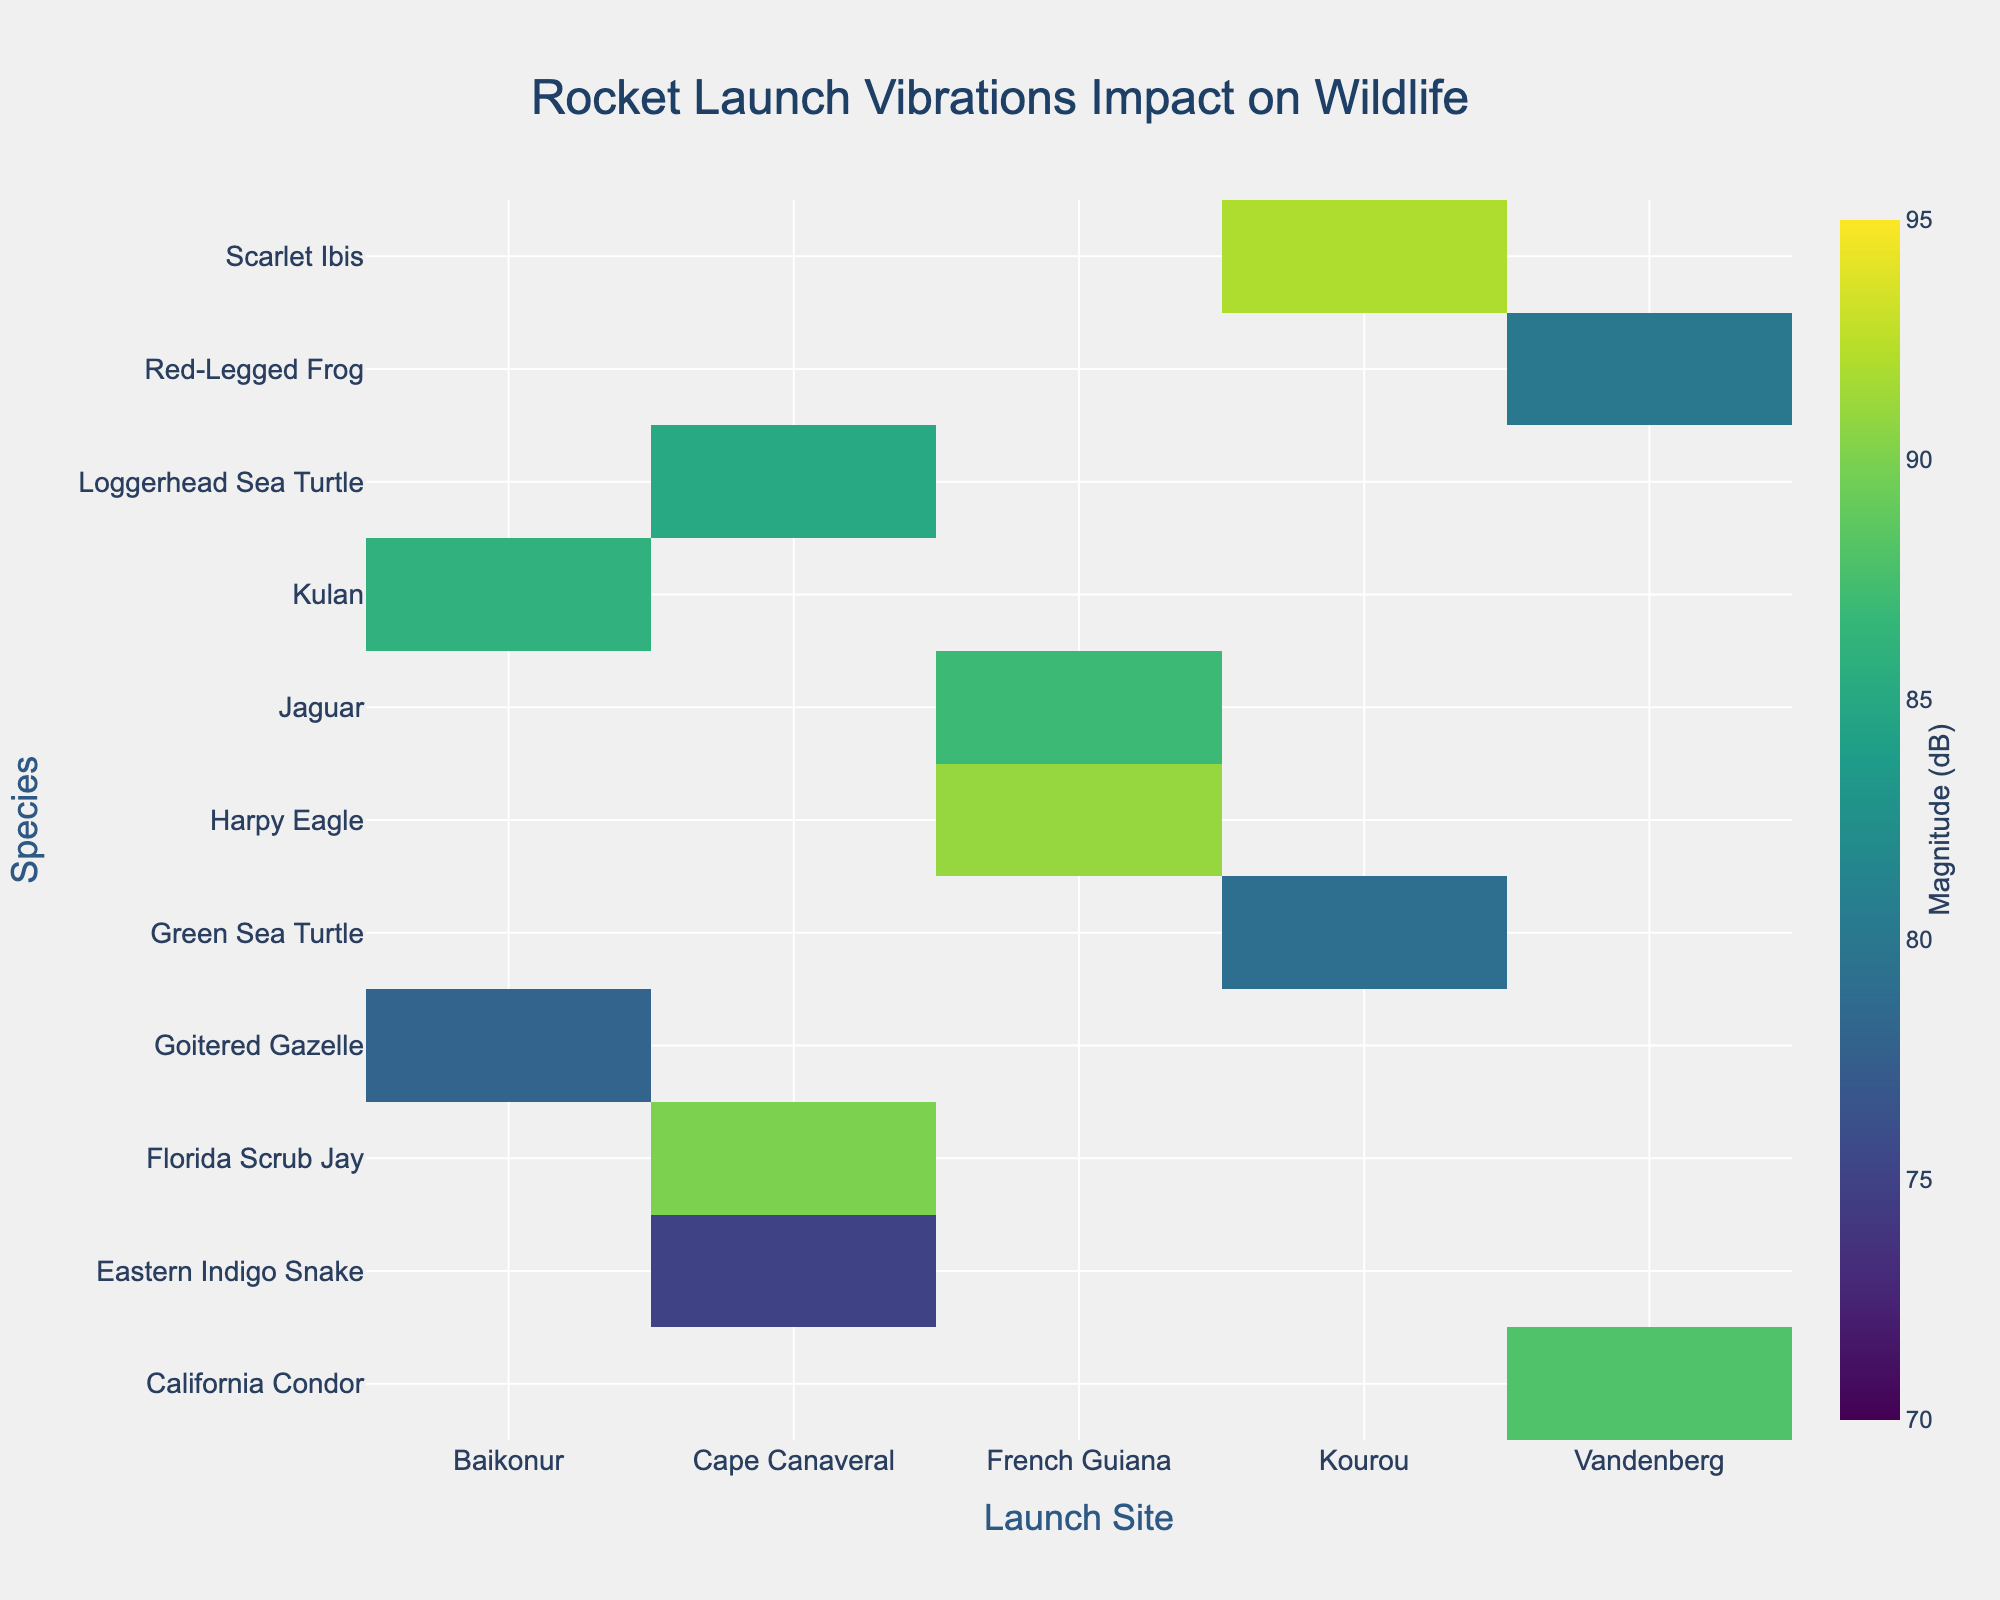what is the title of the heatmap? The title of the heatmap can be found at the top of the figure. It is usually displayed in a larger or bold font compared to the rest of the text in the figure.
Answer: Rocket Launch Vibrations Impact on Wildlife Which species experienced the highest vibration magnitude at Kourou? Find the cell in the Kourou column with the highest value. The y-axis will tell you which species this value corresponds to.
Answer: Scarlet Ibis What is the average vibration magnitude experienced by wildlife species at Cape Canaveral? To find the average, sum the magnitudes of all species listed under Cape Canaveral and divide by the number of species. The values are 85, 75, and 90. Sum these to get 250 and then divide by 3.
Answer: 83.3 Which launch site shows the lowest range of vibration magnitudes across all species? Look at the values in each column. Calculate the range by subtracting the smallest value from the largest value in each column. Compare ranges for all columns.
Answer: Cape Canaveral (range = 90-75 = 15) How does the vibration magnitude for the Loggerhead Sea Turtle compare between Cape Canaveral and Kourou? Locate Loggerhead Sea Turtle in the y-axis and compare the values in Cape Canaveral's and Kourou's columns. Since Kourou doesn't have a value for Loggerhead Sea Turtle, the comparison can only be made for Cape Canaveral.
Answer: Present in Cape Canaveral only, magnitude is 85 dB Which wildlife habitat faced the highest magnitude of vibrations overall? Scan through all the magnitudes in the heatmap and find the highest value, then use the y-axis to see the corresponding species and x-axis for the launch site.
Answer: Scarlet Ibis, 92 dB What is the median vibration magnitude for species at Vandenberg? List the magnitudes for Vandenberg: 88 and 80. Since there are only two values, the median is the average of these two values. (88+80)/2 = 84.
Answer: 84 Between French Guiana and Baikonur, which launch site caused higher average magnitude impacts on wildlife? Calculate the average magnitude for each site by summing their magnitudes and dividing by the number of species listed. French Guiana: (87+91)/2 = 89, Baikonur: (86+78)/2 = 82.
Answer: French Guiana Is there any species that has data recorded at both Cape Canaveral and Vandenberg? Look at the y-axis (species) and check if any species name repeats across both the Cape Canaveral and Vandenberg columns.
Answer: No 